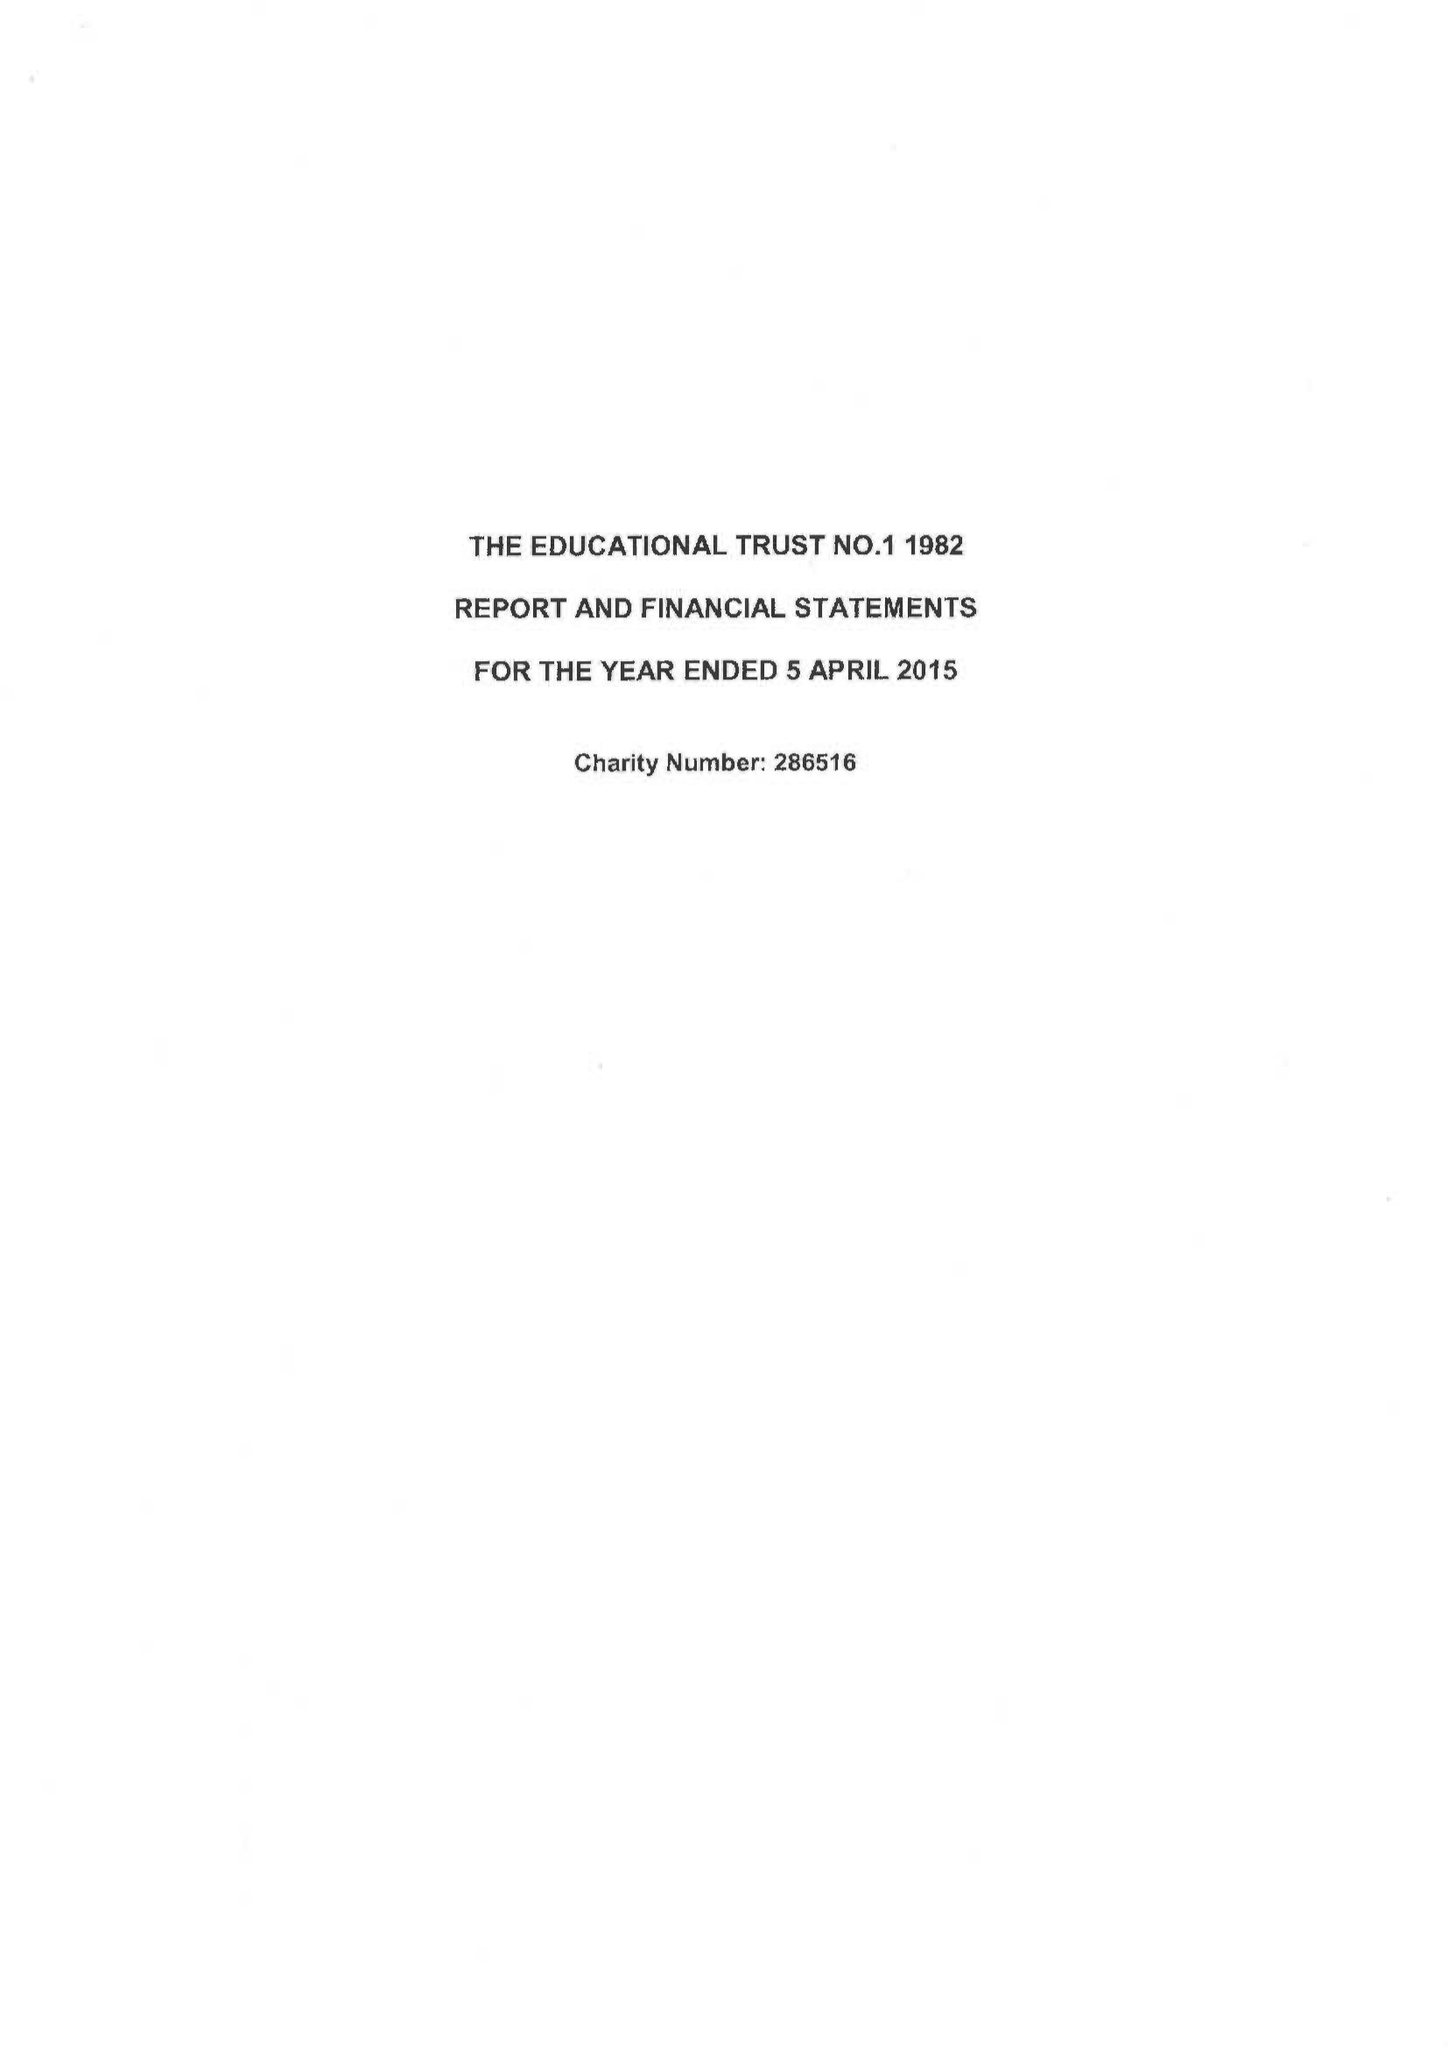What is the value for the address__postcode?
Answer the question using a single word or phrase. PO15 7PA 